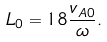<formula> <loc_0><loc_0><loc_500><loc_500>L _ { 0 } = 1 8 \frac { v _ { A 0 } } { \omega } .</formula> 